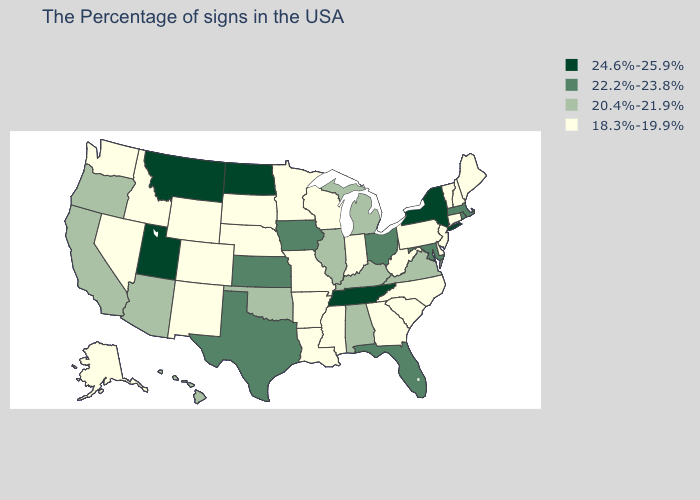What is the value of Kansas?
Write a very short answer. 22.2%-23.8%. Which states have the highest value in the USA?
Be succinct. New York, Tennessee, North Dakota, Utah, Montana. Name the states that have a value in the range 18.3%-19.9%?
Be succinct. Maine, New Hampshire, Vermont, Connecticut, New Jersey, Delaware, Pennsylvania, North Carolina, South Carolina, West Virginia, Georgia, Indiana, Wisconsin, Mississippi, Louisiana, Missouri, Arkansas, Minnesota, Nebraska, South Dakota, Wyoming, Colorado, New Mexico, Idaho, Nevada, Washington, Alaska. What is the value of Louisiana?
Give a very brief answer. 18.3%-19.9%. What is the value of Minnesota?
Be succinct. 18.3%-19.9%. What is the lowest value in the South?
Give a very brief answer. 18.3%-19.9%. What is the value of South Carolina?
Quick response, please. 18.3%-19.9%. Among the states that border California , which have the highest value?
Write a very short answer. Arizona, Oregon. Is the legend a continuous bar?
Short answer required. No. Does the first symbol in the legend represent the smallest category?
Write a very short answer. No. Name the states that have a value in the range 18.3%-19.9%?
Short answer required. Maine, New Hampshire, Vermont, Connecticut, New Jersey, Delaware, Pennsylvania, North Carolina, South Carolina, West Virginia, Georgia, Indiana, Wisconsin, Mississippi, Louisiana, Missouri, Arkansas, Minnesota, Nebraska, South Dakota, Wyoming, Colorado, New Mexico, Idaho, Nevada, Washington, Alaska. Name the states that have a value in the range 20.4%-21.9%?
Quick response, please. Virginia, Michigan, Kentucky, Alabama, Illinois, Oklahoma, Arizona, California, Oregon, Hawaii. What is the highest value in states that border Louisiana?
Give a very brief answer. 22.2%-23.8%. What is the value of Nevada?
Be succinct. 18.3%-19.9%. What is the value of New Mexico?
Give a very brief answer. 18.3%-19.9%. 